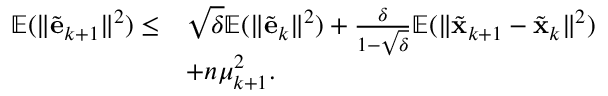Convert formula to latex. <formula><loc_0><loc_0><loc_500><loc_500>\begin{array} { r l } { \mathbb { E } ( \| \tilde { e } _ { k + 1 } \| ^ { 2 } ) \leq } & { \sqrt { \delta } \mathbb { E } ( \| \tilde { e } _ { k } \| ^ { 2 } ) + \frac { \delta } { 1 - \sqrt { \delta } } \mathbb { E } ( \| \tilde { x } _ { k + 1 } - \tilde { x } _ { k } \| ^ { 2 } ) } \\ & { + n \mu _ { k + 1 } ^ { 2 } . } \end{array}</formula> 